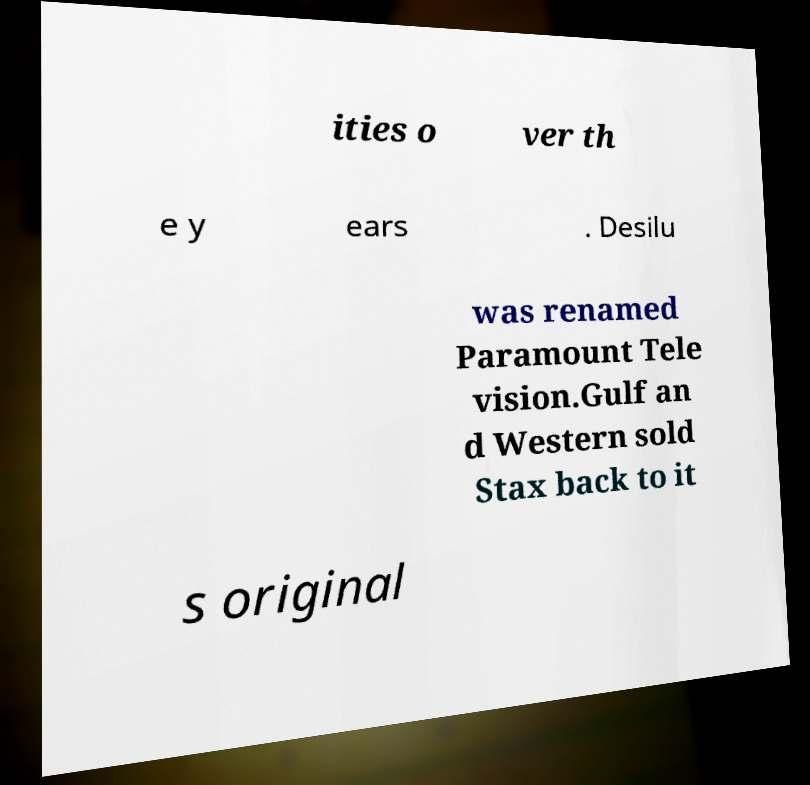Could you assist in decoding the text presented in this image and type it out clearly? ities o ver th e y ears . Desilu was renamed Paramount Tele vision.Gulf an d Western sold Stax back to it s original 